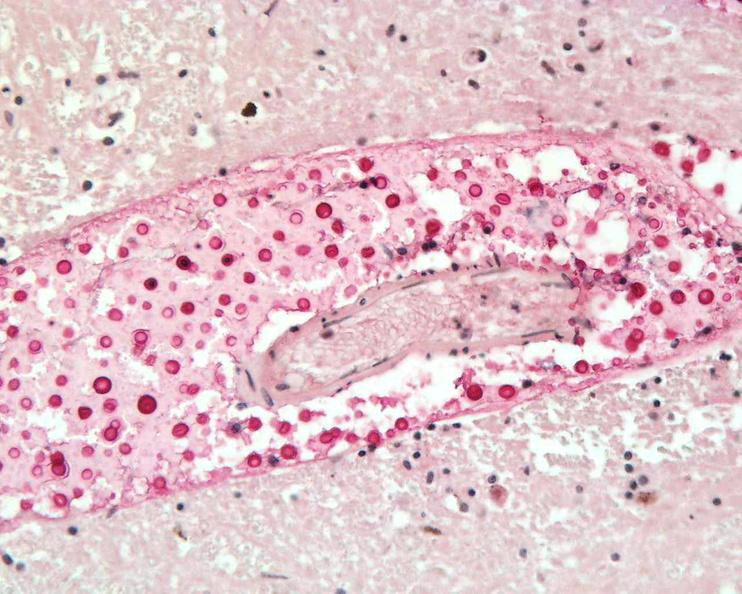do mucicarmine stain?
Answer the question using a single word or phrase. Yes 